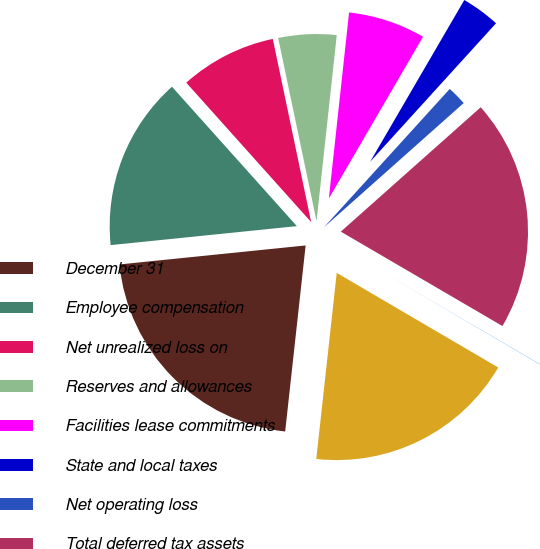<chart> <loc_0><loc_0><loc_500><loc_500><pie_chart><fcel>December 31<fcel>Employee compensation<fcel>Net unrealized loss on<fcel>Reserves and allowances<fcel>Facilities lease commitments<fcel>State and local taxes<fcel>Net operating loss<fcel>Total deferred tax assets<fcel>Valuation allowance<fcel>Deferred tax assets - net of<nl><fcel>21.64%<fcel>14.99%<fcel>8.34%<fcel>5.01%<fcel>6.67%<fcel>3.35%<fcel>1.69%<fcel>19.98%<fcel>0.02%<fcel>18.31%<nl></chart> 